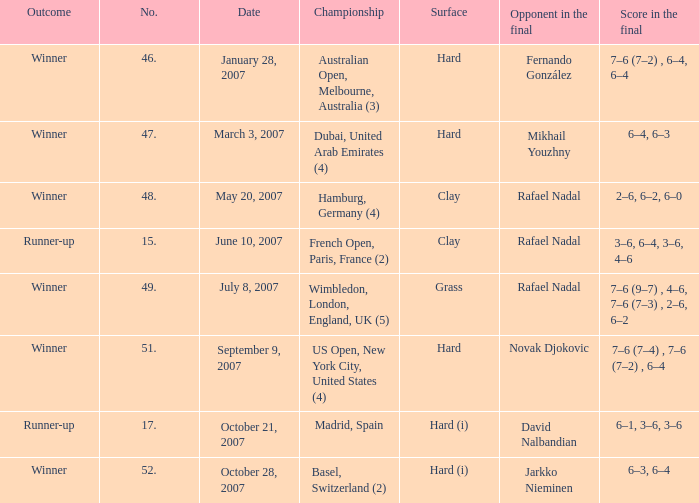The score in the finale is 2-6, 6-2, 6-0, on which surface? Clay. 